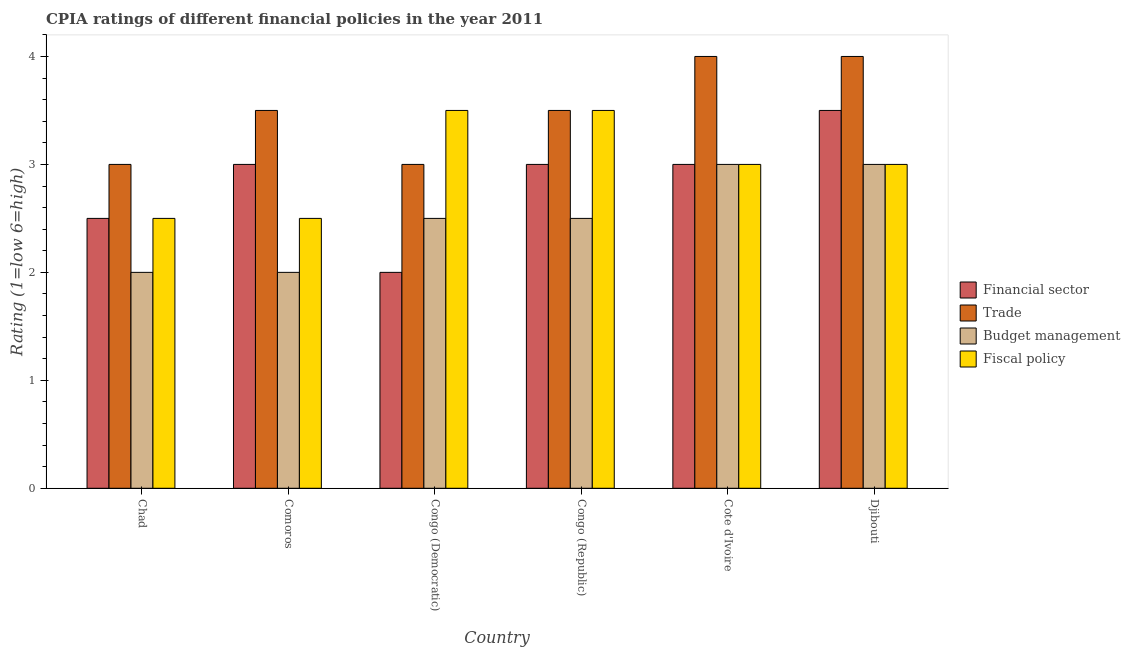How many groups of bars are there?
Give a very brief answer. 6. How many bars are there on the 6th tick from the left?
Offer a very short reply. 4. What is the label of the 4th group of bars from the left?
Keep it short and to the point. Congo (Republic). In how many cases, is the number of bars for a given country not equal to the number of legend labels?
Keep it short and to the point. 0. What is the cpia rating of fiscal policy in Congo (Democratic)?
Your response must be concise. 3.5. Across all countries, what is the maximum cpia rating of financial sector?
Ensure brevity in your answer.  3.5. In which country was the cpia rating of trade maximum?
Keep it short and to the point. Cote d'Ivoire. In which country was the cpia rating of fiscal policy minimum?
Your answer should be very brief. Chad. In how many countries, is the cpia rating of trade greater than 0.8 ?
Give a very brief answer. 6. What is the ratio of the cpia rating of financial sector in Chad to that in Comoros?
Your answer should be compact. 0.83. Is the difference between the cpia rating of trade in Chad and Comoros greater than the difference between the cpia rating of financial sector in Chad and Comoros?
Your response must be concise. No. What is the difference between the highest and the second highest cpia rating of fiscal policy?
Offer a terse response. 0. Is it the case that in every country, the sum of the cpia rating of fiscal policy and cpia rating of financial sector is greater than the sum of cpia rating of budget management and cpia rating of trade?
Offer a very short reply. No. What does the 1st bar from the left in Cote d'Ivoire represents?
Keep it short and to the point. Financial sector. What does the 2nd bar from the right in Djibouti represents?
Provide a succinct answer. Budget management. How many countries are there in the graph?
Your answer should be compact. 6. What is the difference between two consecutive major ticks on the Y-axis?
Ensure brevity in your answer.  1. Where does the legend appear in the graph?
Provide a succinct answer. Center right. How many legend labels are there?
Your answer should be compact. 4. What is the title of the graph?
Your answer should be very brief. CPIA ratings of different financial policies in the year 2011. Does "Agricultural land" appear as one of the legend labels in the graph?
Provide a succinct answer. No. What is the label or title of the X-axis?
Provide a succinct answer. Country. What is the Rating (1=low 6=high) in Financial sector in Chad?
Provide a short and direct response. 2.5. What is the Rating (1=low 6=high) of Budget management in Chad?
Keep it short and to the point. 2. What is the Rating (1=low 6=high) in Fiscal policy in Chad?
Provide a short and direct response. 2.5. What is the Rating (1=low 6=high) in Financial sector in Comoros?
Ensure brevity in your answer.  3. What is the Rating (1=low 6=high) in Fiscal policy in Comoros?
Give a very brief answer. 2.5. What is the Rating (1=low 6=high) of Financial sector in Congo (Democratic)?
Your answer should be compact. 2. What is the Rating (1=low 6=high) in Trade in Congo (Democratic)?
Provide a succinct answer. 3. What is the Rating (1=low 6=high) in Budget management in Congo (Democratic)?
Ensure brevity in your answer.  2.5. What is the Rating (1=low 6=high) in Financial sector in Congo (Republic)?
Offer a terse response. 3. What is the Rating (1=low 6=high) of Trade in Congo (Republic)?
Your answer should be very brief. 3.5. What is the Rating (1=low 6=high) of Budget management in Congo (Republic)?
Offer a terse response. 2.5. What is the Rating (1=low 6=high) of Budget management in Cote d'Ivoire?
Provide a short and direct response. 3. What is the Rating (1=low 6=high) of Fiscal policy in Cote d'Ivoire?
Make the answer very short. 3. What is the Rating (1=low 6=high) in Trade in Djibouti?
Ensure brevity in your answer.  4. What is the Rating (1=low 6=high) of Fiscal policy in Djibouti?
Your answer should be very brief. 3. Across all countries, what is the maximum Rating (1=low 6=high) in Financial sector?
Provide a succinct answer. 3.5. Across all countries, what is the minimum Rating (1=low 6=high) of Financial sector?
Offer a terse response. 2. Across all countries, what is the minimum Rating (1=low 6=high) of Trade?
Make the answer very short. 3. Across all countries, what is the minimum Rating (1=low 6=high) of Budget management?
Offer a very short reply. 2. Across all countries, what is the minimum Rating (1=low 6=high) in Fiscal policy?
Give a very brief answer. 2.5. What is the total Rating (1=low 6=high) of Financial sector in the graph?
Your response must be concise. 17. What is the total Rating (1=low 6=high) of Trade in the graph?
Your answer should be very brief. 21. What is the total Rating (1=low 6=high) of Budget management in the graph?
Your answer should be very brief. 15. What is the total Rating (1=low 6=high) of Fiscal policy in the graph?
Your answer should be compact. 18. What is the difference between the Rating (1=low 6=high) of Financial sector in Chad and that in Comoros?
Ensure brevity in your answer.  -0.5. What is the difference between the Rating (1=low 6=high) of Budget management in Chad and that in Comoros?
Provide a short and direct response. 0. What is the difference between the Rating (1=low 6=high) of Financial sector in Chad and that in Congo (Democratic)?
Give a very brief answer. 0.5. What is the difference between the Rating (1=low 6=high) in Trade in Chad and that in Congo (Democratic)?
Ensure brevity in your answer.  0. What is the difference between the Rating (1=low 6=high) in Financial sector in Chad and that in Congo (Republic)?
Provide a succinct answer. -0.5. What is the difference between the Rating (1=low 6=high) of Trade in Chad and that in Congo (Republic)?
Your answer should be compact. -0.5. What is the difference between the Rating (1=low 6=high) of Financial sector in Chad and that in Cote d'Ivoire?
Your answer should be compact. -0.5. What is the difference between the Rating (1=low 6=high) in Trade in Chad and that in Cote d'Ivoire?
Ensure brevity in your answer.  -1. What is the difference between the Rating (1=low 6=high) in Fiscal policy in Chad and that in Cote d'Ivoire?
Give a very brief answer. -0.5. What is the difference between the Rating (1=low 6=high) in Financial sector in Chad and that in Djibouti?
Your answer should be very brief. -1. What is the difference between the Rating (1=low 6=high) of Trade in Chad and that in Djibouti?
Provide a short and direct response. -1. What is the difference between the Rating (1=low 6=high) of Budget management in Chad and that in Djibouti?
Keep it short and to the point. -1. What is the difference between the Rating (1=low 6=high) of Trade in Comoros and that in Congo (Democratic)?
Your answer should be compact. 0.5. What is the difference between the Rating (1=low 6=high) of Budget management in Comoros and that in Congo (Democratic)?
Give a very brief answer. -0.5. What is the difference between the Rating (1=low 6=high) in Fiscal policy in Comoros and that in Congo (Democratic)?
Make the answer very short. -1. What is the difference between the Rating (1=low 6=high) of Financial sector in Comoros and that in Congo (Republic)?
Offer a terse response. 0. What is the difference between the Rating (1=low 6=high) in Trade in Comoros and that in Congo (Republic)?
Ensure brevity in your answer.  0. What is the difference between the Rating (1=low 6=high) in Budget management in Comoros and that in Congo (Republic)?
Make the answer very short. -0.5. What is the difference between the Rating (1=low 6=high) of Fiscal policy in Comoros and that in Congo (Republic)?
Offer a very short reply. -1. What is the difference between the Rating (1=low 6=high) of Financial sector in Comoros and that in Cote d'Ivoire?
Provide a succinct answer. 0. What is the difference between the Rating (1=low 6=high) in Trade in Comoros and that in Djibouti?
Your answer should be compact. -0.5. What is the difference between the Rating (1=low 6=high) of Budget management in Comoros and that in Djibouti?
Provide a short and direct response. -1. What is the difference between the Rating (1=low 6=high) of Financial sector in Congo (Democratic) and that in Congo (Republic)?
Your response must be concise. -1. What is the difference between the Rating (1=low 6=high) of Trade in Congo (Democratic) and that in Congo (Republic)?
Your answer should be very brief. -0.5. What is the difference between the Rating (1=low 6=high) in Budget management in Congo (Democratic) and that in Congo (Republic)?
Make the answer very short. 0. What is the difference between the Rating (1=low 6=high) in Fiscal policy in Congo (Democratic) and that in Congo (Republic)?
Your response must be concise. 0. What is the difference between the Rating (1=low 6=high) of Financial sector in Congo (Democratic) and that in Cote d'Ivoire?
Keep it short and to the point. -1. What is the difference between the Rating (1=low 6=high) in Budget management in Congo (Democratic) and that in Cote d'Ivoire?
Provide a short and direct response. -0.5. What is the difference between the Rating (1=low 6=high) in Fiscal policy in Congo (Democratic) and that in Cote d'Ivoire?
Provide a succinct answer. 0.5. What is the difference between the Rating (1=low 6=high) of Financial sector in Congo (Democratic) and that in Djibouti?
Ensure brevity in your answer.  -1.5. What is the difference between the Rating (1=low 6=high) in Fiscal policy in Congo (Democratic) and that in Djibouti?
Give a very brief answer. 0.5. What is the difference between the Rating (1=low 6=high) in Financial sector in Congo (Republic) and that in Cote d'Ivoire?
Keep it short and to the point. 0. What is the difference between the Rating (1=low 6=high) in Trade in Congo (Republic) and that in Djibouti?
Offer a terse response. -0.5. What is the difference between the Rating (1=low 6=high) in Financial sector in Cote d'Ivoire and that in Djibouti?
Your answer should be very brief. -0.5. What is the difference between the Rating (1=low 6=high) of Trade in Cote d'Ivoire and that in Djibouti?
Offer a very short reply. 0. What is the difference between the Rating (1=low 6=high) in Budget management in Cote d'Ivoire and that in Djibouti?
Keep it short and to the point. 0. What is the difference between the Rating (1=low 6=high) in Fiscal policy in Cote d'Ivoire and that in Djibouti?
Your response must be concise. 0. What is the difference between the Rating (1=low 6=high) in Trade in Chad and the Rating (1=low 6=high) in Budget management in Comoros?
Offer a very short reply. 1. What is the difference between the Rating (1=low 6=high) of Financial sector in Chad and the Rating (1=low 6=high) of Trade in Congo (Democratic)?
Give a very brief answer. -0.5. What is the difference between the Rating (1=low 6=high) in Financial sector in Chad and the Rating (1=low 6=high) in Budget management in Congo (Democratic)?
Offer a terse response. 0. What is the difference between the Rating (1=low 6=high) of Financial sector in Chad and the Rating (1=low 6=high) of Fiscal policy in Congo (Democratic)?
Your answer should be compact. -1. What is the difference between the Rating (1=low 6=high) in Trade in Chad and the Rating (1=low 6=high) in Budget management in Congo (Democratic)?
Keep it short and to the point. 0.5. What is the difference between the Rating (1=low 6=high) in Budget management in Chad and the Rating (1=low 6=high) in Fiscal policy in Congo (Democratic)?
Keep it short and to the point. -1.5. What is the difference between the Rating (1=low 6=high) in Financial sector in Chad and the Rating (1=low 6=high) in Budget management in Congo (Republic)?
Your answer should be very brief. 0. What is the difference between the Rating (1=low 6=high) of Trade in Chad and the Rating (1=low 6=high) of Budget management in Congo (Republic)?
Ensure brevity in your answer.  0.5. What is the difference between the Rating (1=low 6=high) of Budget management in Chad and the Rating (1=low 6=high) of Fiscal policy in Congo (Republic)?
Your answer should be very brief. -1.5. What is the difference between the Rating (1=low 6=high) of Financial sector in Chad and the Rating (1=low 6=high) of Trade in Cote d'Ivoire?
Provide a short and direct response. -1.5. What is the difference between the Rating (1=low 6=high) of Trade in Chad and the Rating (1=low 6=high) of Fiscal policy in Cote d'Ivoire?
Give a very brief answer. 0. What is the difference between the Rating (1=low 6=high) in Budget management in Chad and the Rating (1=low 6=high) in Fiscal policy in Cote d'Ivoire?
Provide a succinct answer. -1. What is the difference between the Rating (1=low 6=high) in Financial sector in Chad and the Rating (1=low 6=high) in Trade in Djibouti?
Give a very brief answer. -1.5. What is the difference between the Rating (1=low 6=high) in Trade in Chad and the Rating (1=low 6=high) in Budget management in Djibouti?
Provide a succinct answer. 0. What is the difference between the Rating (1=low 6=high) of Financial sector in Comoros and the Rating (1=low 6=high) of Trade in Congo (Democratic)?
Ensure brevity in your answer.  0. What is the difference between the Rating (1=low 6=high) of Financial sector in Comoros and the Rating (1=low 6=high) of Fiscal policy in Congo (Democratic)?
Offer a terse response. -0.5. What is the difference between the Rating (1=low 6=high) of Trade in Comoros and the Rating (1=low 6=high) of Budget management in Congo (Democratic)?
Your answer should be very brief. 1. What is the difference between the Rating (1=low 6=high) in Budget management in Comoros and the Rating (1=low 6=high) in Fiscal policy in Congo (Democratic)?
Make the answer very short. -1.5. What is the difference between the Rating (1=low 6=high) in Financial sector in Comoros and the Rating (1=low 6=high) in Budget management in Congo (Republic)?
Offer a terse response. 0.5. What is the difference between the Rating (1=low 6=high) of Trade in Comoros and the Rating (1=low 6=high) of Budget management in Congo (Republic)?
Provide a succinct answer. 1. What is the difference between the Rating (1=low 6=high) of Trade in Comoros and the Rating (1=low 6=high) of Fiscal policy in Congo (Republic)?
Give a very brief answer. 0. What is the difference between the Rating (1=low 6=high) in Budget management in Comoros and the Rating (1=low 6=high) in Fiscal policy in Congo (Republic)?
Your answer should be compact. -1.5. What is the difference between the Rating (1=low 6=high) in Financial sector in Comoros and the Rating (1=low 6=high) in Budget management in Cote d'Ivoire?
Provide a short and direct response. 0. What is the difference between the Rating (1=low 6=high) of Financial sector in Comoros and the Rating (1=low 6=high) of Fiscal policy in Cote d'Ivoire?
Ensure brevity in your answer.  0. What is the difference between the Rating (1=low 6=high) in Trade in Comoros and the Rating (1=low 6=high) in Budget management in Cote d'Ivoire?
Keep it short and to the point. 0.5. What is the difference between the Rating (1=low 6=high) in Budget management in Comoros and the Rating (1=low 6=high) in Fiscal policy in Cote d'Ivoire?
Offer a terse response. -1. What is the difference between the Rating (1=low 6=high) of Financial sector in Comoros and the Rating (1=low 6=high) of Budget management in Djibouti?
Provide a short and direct response. 0. What is the difference between the Rating (1=low 6=high) of Trade in Comoros and the Rating (1=low 6=high) of Budget management in Djibouti?
Keep it short and to the point. 0.5. What is the difference between the Rating (1=low 6=high) of Budget management in Comoros and the Rating (1=low 6=high) of Fiscal policy in Djibouti?
Offer a terse response. -1. What is the difference between the Rating (1=low 6=high) of Financial sector in Congo (Democratic) and the Rating (1=low 6=high) of Fiscal policy in Congo (Republic)?
Provide a short and direct response. -1.5. What is the difference between the Rating (1=low 6=high) in Trade in Congo (Democratic) and the Rating (1=low 6=high) in Fiscal policy in Congo (Republic)?
Keep it short and to the point. -0.5. What is the difference between the Rating (1=low 6=high) in Budget management in Congo (Democratic) and the Rating (1=low 6=high) in Fiscal policy in Congo (Republic)?
Give a very brief answer. -1. What is the difference between the Rating (1=low 6=high) in Financial sector in Congo (Democratic) and the Rating (1=low 6=high) in Trade in Cote d'Ivoire?
Your response must be concise. -2. What is the difference between the Rating (1=low 6=high) in Financial sector in Congo (Democratic) and the Rating (1=low 6=high) in Fiscal policy in Cote d'Ivoire?
Give a very brief answer. -1. What is the difference between the Rating (1=low 6=high) in Financial sector in Congo (Democratic) and the Rating (1=low 6=high) in Trade in Djibouti?
Make the answer very short. -2. What is the difference between the Rating (1=low 6=high) in Financial sector in Congo (Democratic) and the Rating (1=low 6=high) in Budget management in Djibouti?
Provide a short and direct response. -1. What is the difference between the Rating (1=low 6=high) of Trade in Congo (Democratic) and the Rating (1=low 6=high) of Budget management in Djibouti?
Offer a very short reply. 0. What is the difference between the Rating (1=low 6=high) of Trade in Congo (Democratic) and the Rating (1=low 6=high) of Fiscal policy in Djibouti?
Offer a very short reply. 0. What is the difference between the Rating (1=low 6=high) of Financial sector in Congo (Republic) and the Rating (1=low 6=high) of Trade in Cote d'Ivoire?
Make the answer very short. -1. What is the difference between the Rating (1=low 6=high) in Budget management in Congo (Republic) and the Rating (1=low 6=high) in Fiscal policy in Cote d'Ivoire?
Make the answer very short. -0.5. What is the difference between the Rating (1=low 6=high) of Financial sector in Congo (Republic) and the Rating (1=low 6=high) of Trade in Djibouti?
Your answer should be compact. -1. What is the difference between the Rating (1=low 6=high) in Financial sector in Congo (Republic) and the Rating (1=low 6=high) in Fiscal policy in Djibouti?
Ensure brevity in your answer.  0. What is the difference between the Rating (1=low 6=high) in Trade in Congo (Republic) and the Rating (1=low 6=high) in Fiscal policy in Djibouti?
Your response must be concise. 0.5. What is the difference between the Rating (1=low 6=high) in Budget management in Congo (Republic) and the Rating (1=low 6=high) in Fiscal policy in Djibouti?
Your response must be concise. -0.5. What is the difference between the Rating (1=low 6=high) of Financial sector in Cote d'Ivoire and the Rating (1=low 6=high) of Trade in Djibouti?
Ensure brevity in your answer.  -1. What is the difference between the Rating (1=low 6=high) in Financial sector in Cote d'Ivoire and the Rating (1=low 6=high) in Budget management in Djibouti?
Offer a very short reply. 0. What is the difference between the Rating (1=low 6=high) in Financial sector in Cote d'Ivoire and the Rating (1=low 6=high) in Fiscal policy in Djibouti?
Give a very brief answer. 0. What is the difference between the Rating (1=low 6=high) in Trade in Cote d'Ivoire and the Rating (1=low 6=high) in Budget management in Djibouti?
Offer a terse response. 1. What is the difference between the Rating (1=low 6=high) of Trade in Cote d'Ivoire and the Rating (1=low 6=high) of Fiscal policy in Djibouti?
Provide a short and direct response. 1. What is the difference between the Rating (1=low 6=high) in Budget management in Cote d'Ivoire and the Rating (1=low 6=high) in Fiscal policy in Djibouti?
Offer a terse response. 0. What is the average Rating (1=low 6=high) of Financial sector per country?
Your answer should be very brief. 2.83. What is the average Rating (1=low 6=high) of Trade per country?
Offer a terse response. 3.5. What is the average Rating (1=low 6=high) in Budget management per country?
Make the answer very short. 2.5. What is the difference between the Rating (1=low 6=high) of Financial sector and Rating (1=low 6=high) of Trade in Chad?
Give a very brief answer. -0.5. What is the difference between the Rating (1=low 6=high) of Financial sector and Rating (1=low 6=high) of Budget management in Chad?
Provide a short and direct response. 0.5. What is the difference between the Rating (1=low 6=high) in Trade and Rating (1=low 6=high) in Fiscal policy in Chad?
Offer a very short reply. 0.5. What is the difference between the Rating (1=low 6=high) in Financial sector and Rating (1=low 6=high) in Budget management in Comoros?
Your answer should be compact. 1. What is the difference between the Rating (1=low 6=high) of Trade and Rating (1=low 6=high) of Fiscal policy in Comoros?
Make the answer very short. 1. What is the difference between the Rating (1=low 6=high) in Financial sector and Rating (1=low 6=high) in Trade in Congo (Democratic)?
Keep it short and to the point. -1. What is the difference between the Rating (1=low 6=high) in Financial sector and Rating (1=low 6=high) in Budget management in Congo (Democratic)?
Provide a succinct answer. -0.5. What is the difference between the Rating (1=low 6=high) in Financial sector and Rating (1=low 6=high) in Fiscal policy in Congo (Democratic)?
Ensure brevity in your answer.  -1.5. What is the difference between the Rating (1=low 6=high) of Trade and Rating (1=low 6=high) of Budget management in Congo (Democratic)?
Give a very brief answer. 0.5. What is the difference between the Rating (1=low 6=high) in Financial sector and Rating (1=low 6=high) in Budget management in Congo (Republic)?
Provide a succinct answer. 0.5. What is the difference between the Rating (1=low 6=high) in Financial sector and Rating (1=low 6=high) in Fiscal policy in Congo (Republic)?
Make the answer very short. -0.5. What is the difference between the Rating (1=low 6=high) of Trade and Rating (1=low 6=high) of Fiscal policy in Congo (Republic)?
Your answer should be compact. 0. What is the difference between the Rating (1=low 6=high) in Budget management and Rating (1=low 6=high) in Fiscal policy in Congo (Republic)?
Keep it short and to the point. -1. What is the difference between the Rating (1=low 6=high) in Financial sector and Rating (1=low 6=high) in Trade in Cote d'Ivoire?
Make the answer very short. -1. What is the difference between the Rating (1=low 6=high) of Financial sector and Rating (1=low 6=high) of Fiscal policy in Cote d'Ivoire?
Make the answer very short. 0. What is the difference between the Rating (1=low 6=high) in Trade and Rating (1=low 6=high) in Budget management in Cote d'Ivoire?
Offer a very short reply. 1. What is the difference between the Rating (1=low 6=high) in Trade and Rating (1=low 6=high) in Fiscal policy in Cote d'Ivoire?
Provide a succinct answer. 1. What is the difference between the Rating (1=low 6=high) of Budget management and Rating (1=low 6=high) of Fiscal policy in Cote d'Ivoire?
Provide a short and direct response. 0. What is the difference between the Rating (1=low 6=high) in Financial sector and Rating (1=low 6=high) in Budget management in Djibouti?
Provide a short and direct response. 0.5. What is the difference between the Rating (1=low 6=high) of Trade and Rating (1=low 6=high) of Budget management in Djibouti?
Give a very brief answer. 1. What is the difference between the Rating (1=low 6=high) in Trade and Rating (1=low 6=high) in Fiscal policy in Djibouti?
Offer a very short reply. 1. What is the ratio of the Rating (1=low 6=high) in Financial sector in Chad to that in Comoros?
Your answer should be very brief. 0.83. What is the ratio of the Rating (1=low 6=high) of Trade in Chad to that in Comoros?
Give a very brief answer. 0.86. What is the ratio of the Rating (1=low 6=high) of Trade in Chad to that in Congo (Democratic)?
Your response must be concise. 1. What is the ratio of the Rating (1=low 6=high) in Fiscal policy in Chad to that in Congo (Democratic)?
Ensure brevity in your answer.  0.71. What is the ratio of the Rating (1=low 6=high) in Fiscal policy in Chad to that in Congo (Republic)?
Make the answer very short. 0.71. What is the ratio of the Rating (1=low 6=high) in Trade in Chad to that in Cote d'Ivoire?
Make the answer very short. 0.75. What is the ratio of the Rating (1=low 6=high) in Budget management in Chad to that in Cote d'Ivoire?
Ensure brevity in your answer.  0.67. What is the ratio of the Rating (1=low 6=high) of Trade in Chad to that in Djibouti?
Your answer should be compact. 0.75. What is the ratio of the Rating (1=low 6=high) in Budget management in Chad to that in Djibouti?
Offer a terse response. 0.67. What is the ratio of the Rating (1=low 6=high) of Trade in Comoros to that in Congo (Democratic)?
Provide a short and direct response. 1.17. What is the ratio of the Rating (1=low 6=high) of Budget management in Comoros to that in Congo (Democratic)?
Ensure brevity in your answer.  0.8. What is the ratio of the Rating (1=low 6=high) of Financial sector in Comoros to that in Congo (Republic)?
Offer a terse response. 1. What is the ratio of the Rating (1=low 6=high) in Trade in Comoros to that in Cote d'Ivoire?
Your answer should be compact. 0.88. What is the ratio of the Rating (1=low 6=high) of Fiscal policy in Comoros to that in Cote d'Ivoire?
Ensure brevity in your answer.  0.83. What is the ratio of the Rating (1=low 6=high) of Financial sector in Comoros to that in Djibouti?
Your answer should be very brief. 0.86. What is the ratio of the Rating (1=low 6=high) of Trade in Comoros to that in Djibouti?
Offer a terse response. 0.88. What is the ratio of the Rating (1=low 6=high) in Fiscal policy in Comoros to that in Djibouti?
Provide a short and direct response. 0.83. What is the ratio of the Rating (1=low 6=high) in Financial sector in Congo (Democratic) to that in Congo (Republic)?
Provide a short and direct response. 0.67. What is the ratio of the Rating (1=low 6=high) of Trade in Congo (Democratic) to that in Congo (Republic)?
Provide a short and direct response. 0.86. What is the ratio of the Rating (1=low 6=high) in Fiscal policy in Congo (Democratic) to that in Congo (Republic)?
Make the answer very short. 1. What is the ratio of the Rating (1=low 6=high) in Trade in Congo (Democratic) to that in Cote d'Ivoire?
Your answer should be very brief. 0.75. What is the ratio of the Rating (1=low 6=high) in Financial sector in Congo (Democratic) to that in Djibouti?
Offer a terse response. 0.57. What is the ratio of the Rating (1=low 6=high) of Fiscal policy in Congo (Democratic) to that in Djibouti?
Give a very brief answer. 1.17. What is the ratio of the Rating (1=low 6=high) of Financial sector in Congo (Republic) to that in Cote d'Ivoire?
Offer a terse response. 1. What is the ratio of the Rating (1=low 6=high) of Trade in Congo (Republic) to that in Cote d'Ivoire?
Provide a short and direct response. 0.88. What is the ratio of the Rating (1=low 6=high) of Financial sector in Congo (Republic) to that in Djibouti?
Provide a succinct answer. 0.86. What is the ratio of the Rating (1=low 6=high) in Financial sector in Cote d'Ivoire to that in Djibouti?
Your response must be concise. 0.86. What is the ratio of the Rating (1=low 6=high) in Budget management in Cote d'Ivoire to that in Djibouti?
Provide a succinct answer. 1. What is the ratio of the Rating (1=low 6=high) of Fiscal policy in Cote d'Ivoire to that in Djibouti?
Keep it short and to the point. 1. What is the difference between the highest and the second highest Rating (1=low 6=high) of Trade?
Offer a terse response. 0. What is the difference between the highest and the second highest Rating (1=low 6=high) in Budget management?
Your answer should be very brief. 0. What is the difference between the highest and the lowest Rating (1=low 6=high) in Financial sector?
Make the answer very short. 1.5. What is the difference between the highest and the lowest Rating (1=low 6=high) of Fiscal policy?
Offer a terse response. 1. 